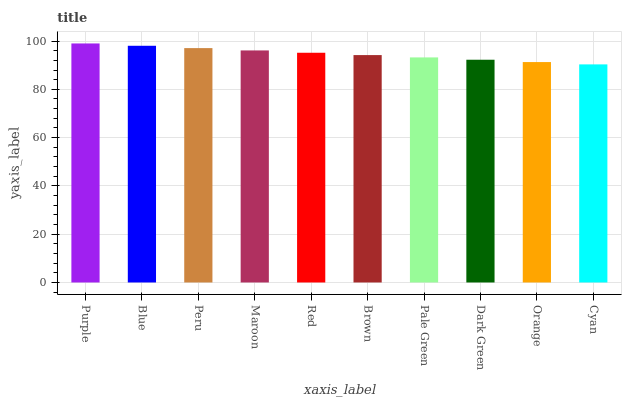Is Blue the minimum?
Answer yes or no. No. Is Blue the maximum?
Answer yes or no. No. Is Purple greater than Blue?
Answer yes or no. Yes. Is Blue less than Purple?
Answer yes or no. Yes. Is Blue greater than Purple?
Answer yes or no. No. Is Purple less than Blue?
Answer yes or no. No. Is Red the high median?
Answer yes or no. Yes. Is Brown the low median?
Answer yes or no. Yes. Is Blue the high median?
Answer yes or no. No. Is Red the low median?
Answer yes or no. No. 